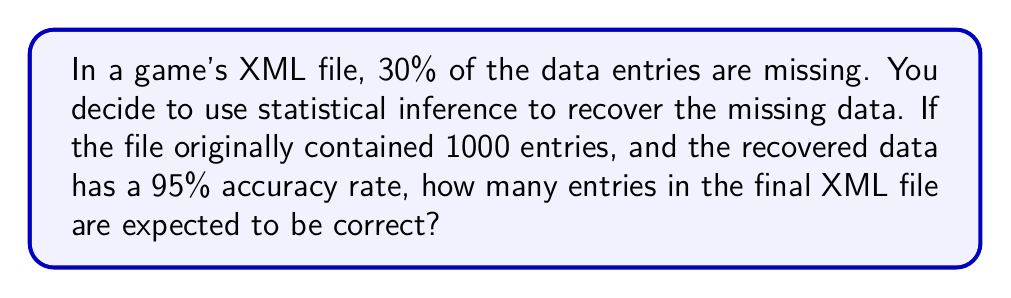Solve this math problem. Let's approach this step-by-step:

1. Calculate the number of existing entries:
   - Total entries: 1000
   - Missing entries: 30% of 1000 = $1000 \times 0.30 = 300$
   - Existing entries: $1000 - 300 = 700$

2. Calculate the number of recovered entries:
   - Missing entries to recover: 300

3. Calculate the number of correctly recovered entries:
   - Accuracy rate: 95%
   - Correctly recovered entries: $300 \times 0.95 = 285$

4. Calculate the total number of correct entries:
   - Existing correct entries: 700 (assuming all existing entries are correct)
   - Correctly recovered entries: 285
   - Total correct entries: $700 + 285 = 985$

Therefore, out of the 1000 entries in the final XML file, 985 are expected to be correct.
Answer: 985 